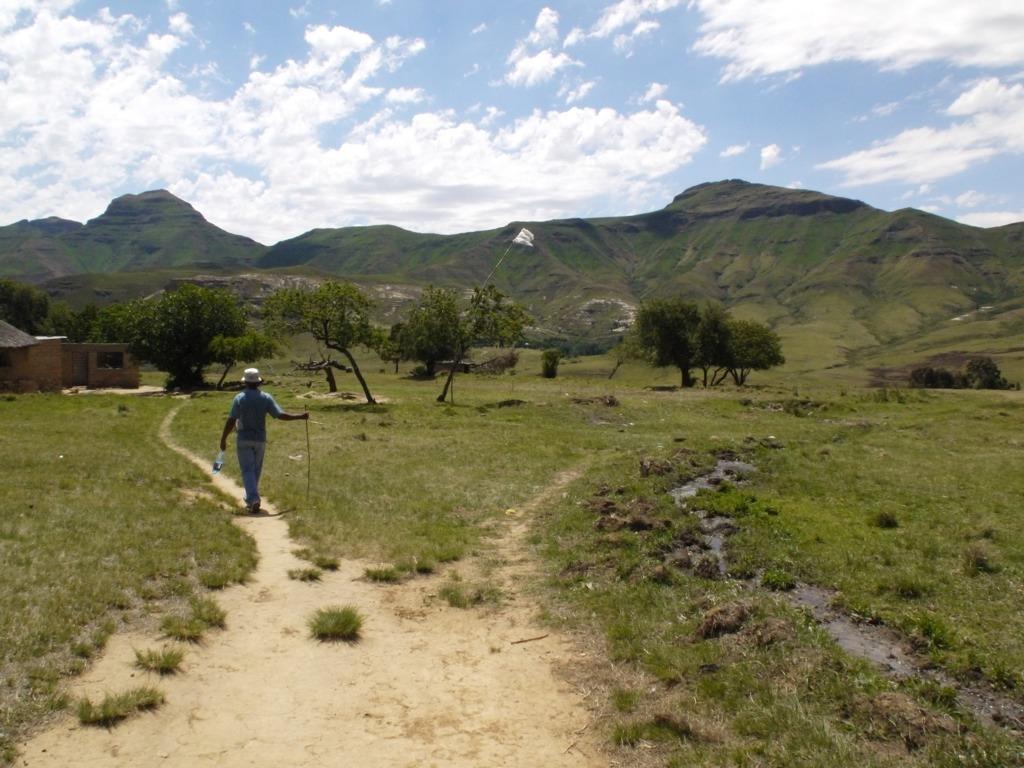In one or two sentences, can you explain what this image depicts? On the left side of the image we can see a house and a man is walking and holding a stick, bottle and wearing a hat. In the background of the image we can see the hills, trees, grass. In the center of the image we can see a flag. At the bottom of the image we can see the ground. At the top of the image we can see the clouds in the sky. 